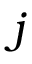Convert formula to latex. <formula><loc_0><loc_0><loc_500><loc_500>j</formula> 